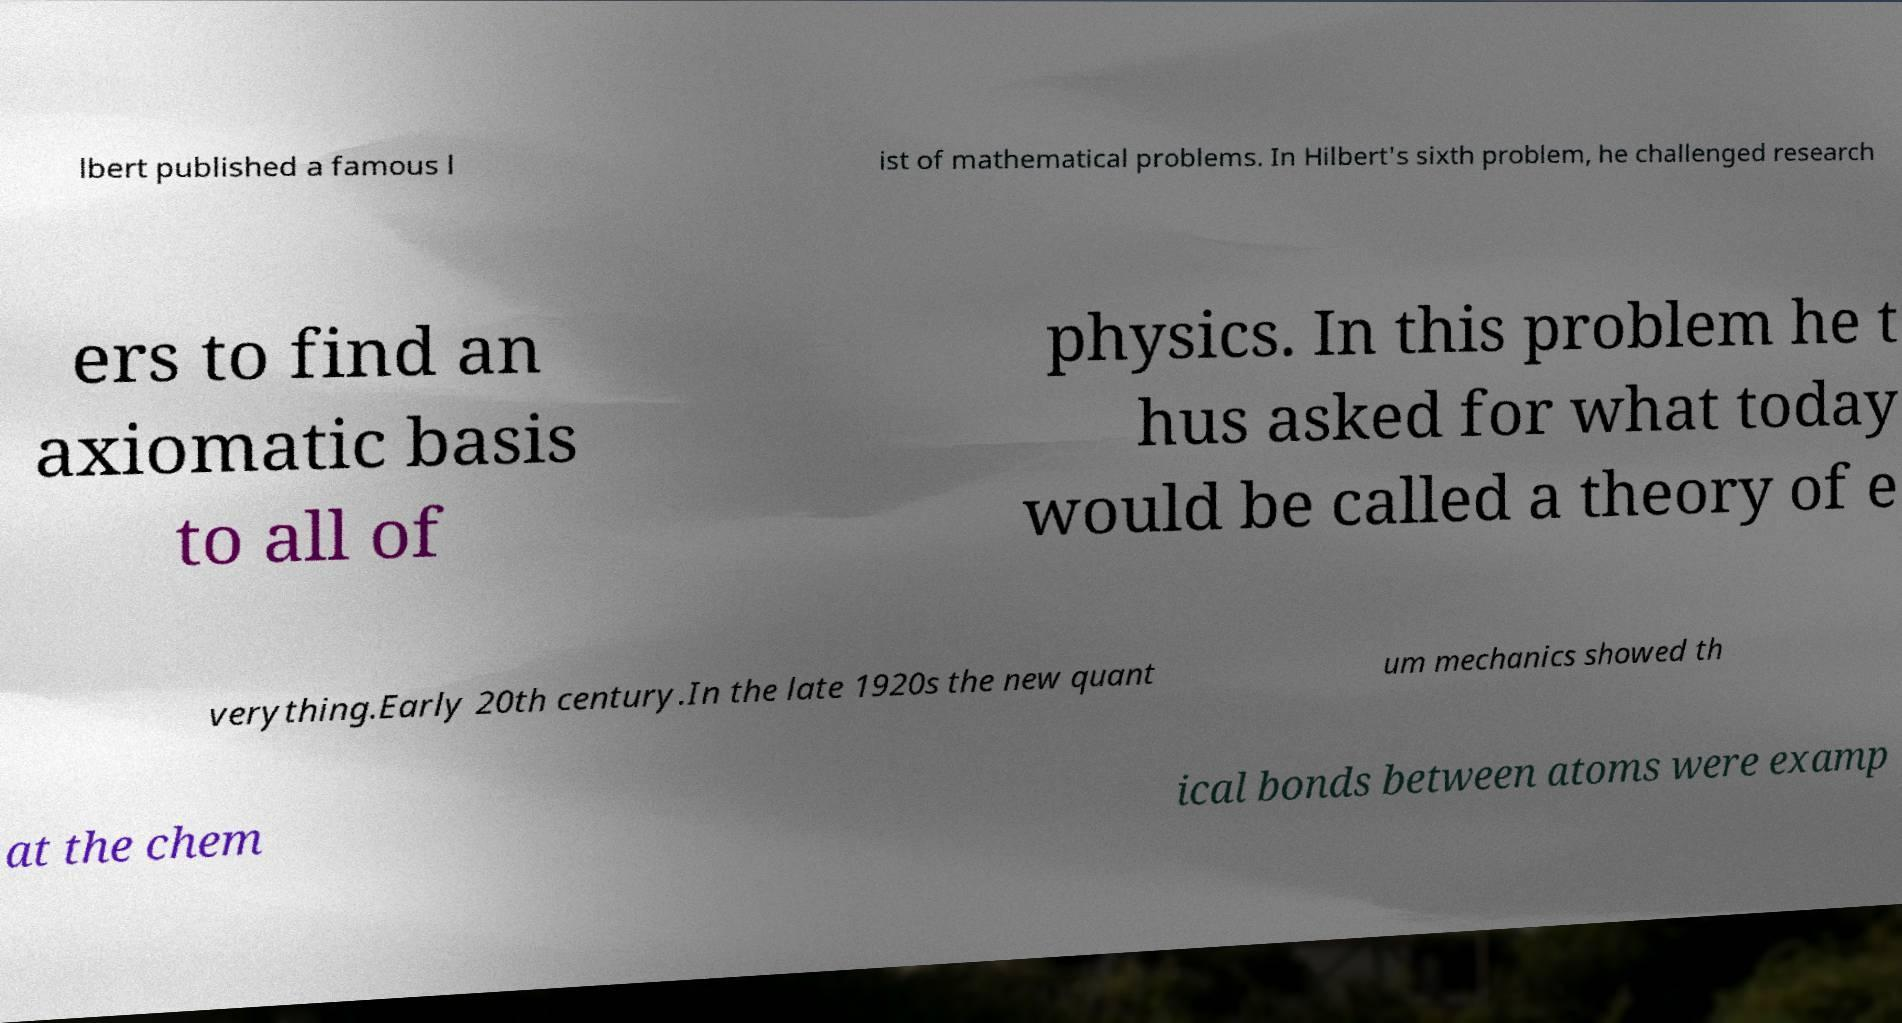Can you read and provide the text displayed in the image?This photo seems to have some interesting text. Can you extract and type it out for me? lbert published a famous l ist of mathematical problems. In Hilbert's sixth problem, he challenged research ers to find an axiomatic basis to all of physics. In this problem he t hus asked for what today would be called a theory of e verything.Early 20th century.In the late 1920s the new quant um mechanics showed th at the chem ical bonds between atoms were examp 